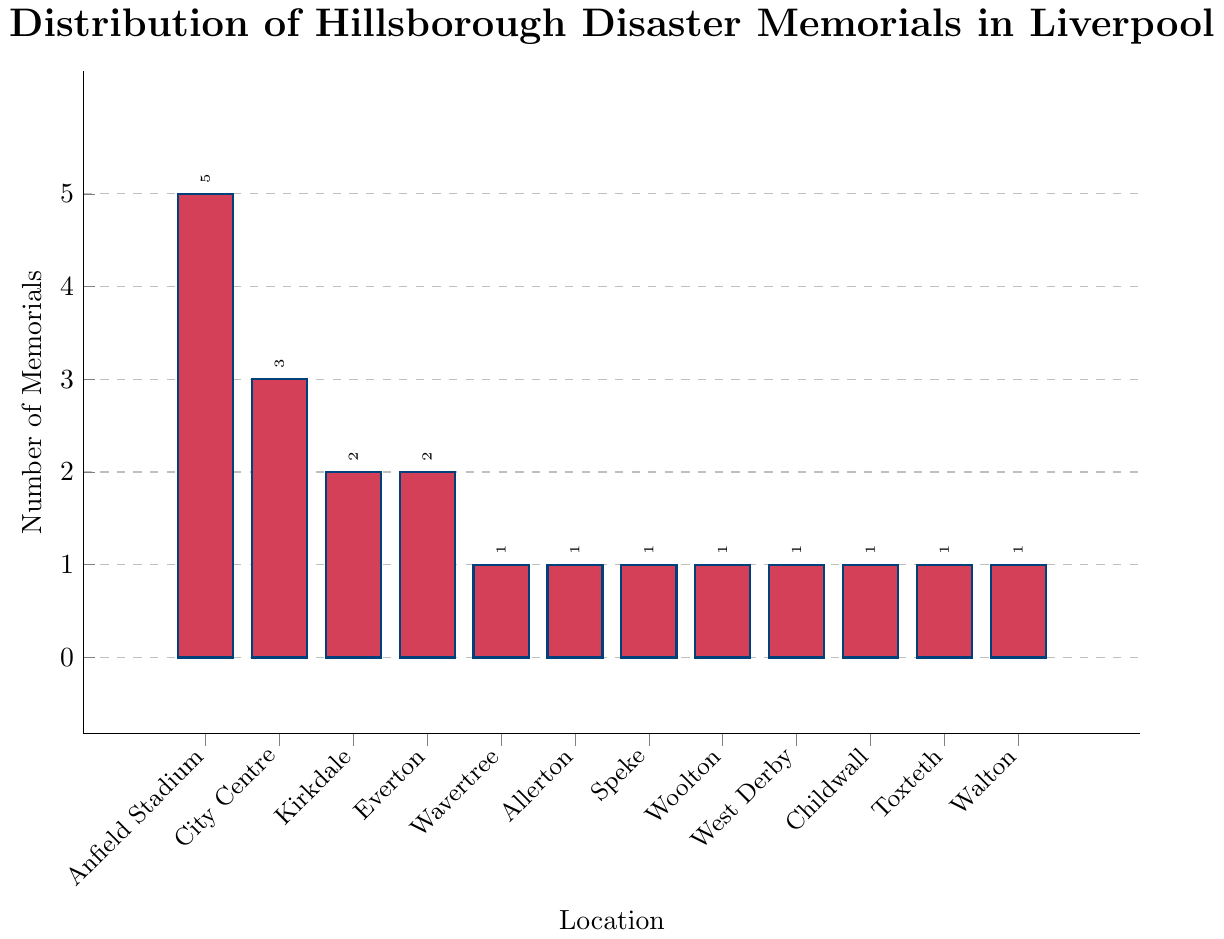Which location has the highest number of memorials? The bar representing "Anfield Stadium" is the tallest, indicating it has the highest number of memorials.
Answer: Anfield Stadium How many memorials are present in the City Centre and Everton combined? The bar for City Centre shows 3 memorials, and the bar for Everton shows 2. Adding these together, 3 + 2 = 5.
Answer: 5 Is the number of memorials in Kirkdale greater than in Walton? The bar for Kirkdale shows 2 memorials, while the bar for Walton shows 1. Since 2 is greater than 1, Kirkdale has more memorials than Walton.
Answer: Yes Which locations have exactly one memorial? The bars for Wavertree, Allerton, Speke, Woolton, West Derby, Childwall, Toxteth, and Walton each show a height corresponding to 1 memorial.
Answer: Wavertree, Allerton, Speke, Woolton, West Derby, Childwall, Toxteth, Walton How many locations have more than one memorial? Counting the bars with heights greater than 1, Anfield Stadium has 5, City Centre has 3, Kirkdale has 2, and Everton has 2. There are 4 such locations.
Answer: 4 Between City Centre and Kirkdale, which location has fewer memorials and by how many? The bar for City Centre shows 3 memorials, while the bar for Kirkdale shows 2. The difference is 3 - 2 = 1. Kirkdale has 1 fewer memorial than City Centre.
Answer: Kirkdale, by 1 What is the total number of memorials represented in the chart? Adding up the memorials from all bars: 5 (Anfield Stadium) + 3 (City Centre) + 2 (Kirkdale) + 2 (Everton) + 1 (each for Wavertree, Allerton, Speke, Woolton, West Derby, Childwall, Toxteth, Walton) = 5 + 3 + 2 + 2 + 1 + 1 + 1 + 1 + 1 + 1 + 1 + 1 = 19.
Answer: 19 Which two locations have the same number of memorials? The bars for Kirkdale and Everton both show a height corresponding to 2 memorials.
Answer: Kirkdale and Everton Are there more memorials in Speke or in Wavertree? The bars for Speke and Wavertree both show a height corresponding to 1 memorial, indicating they have an equal number of memorials.
Answer: They have the same number What is the average number of memorials per location? There are 12 locations in total, and the sum of the memorials is 19. The average is calculated as 19 / 12 ≈ 1.58.
Answer: 1.58 